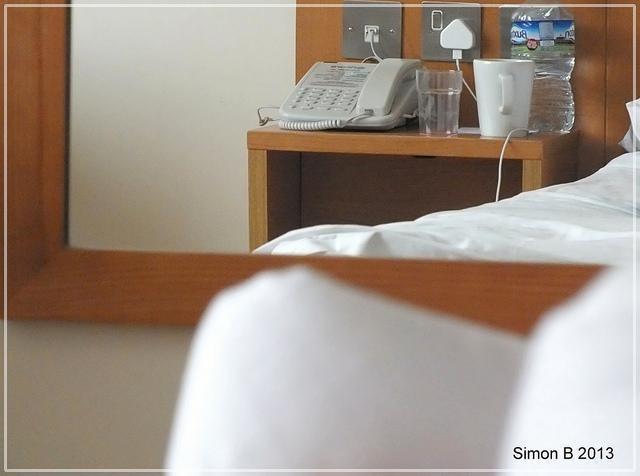How many cups are in the picture?
Give a very brief answer. 2. How many beds are there?
Give a very brief answer. 2. 